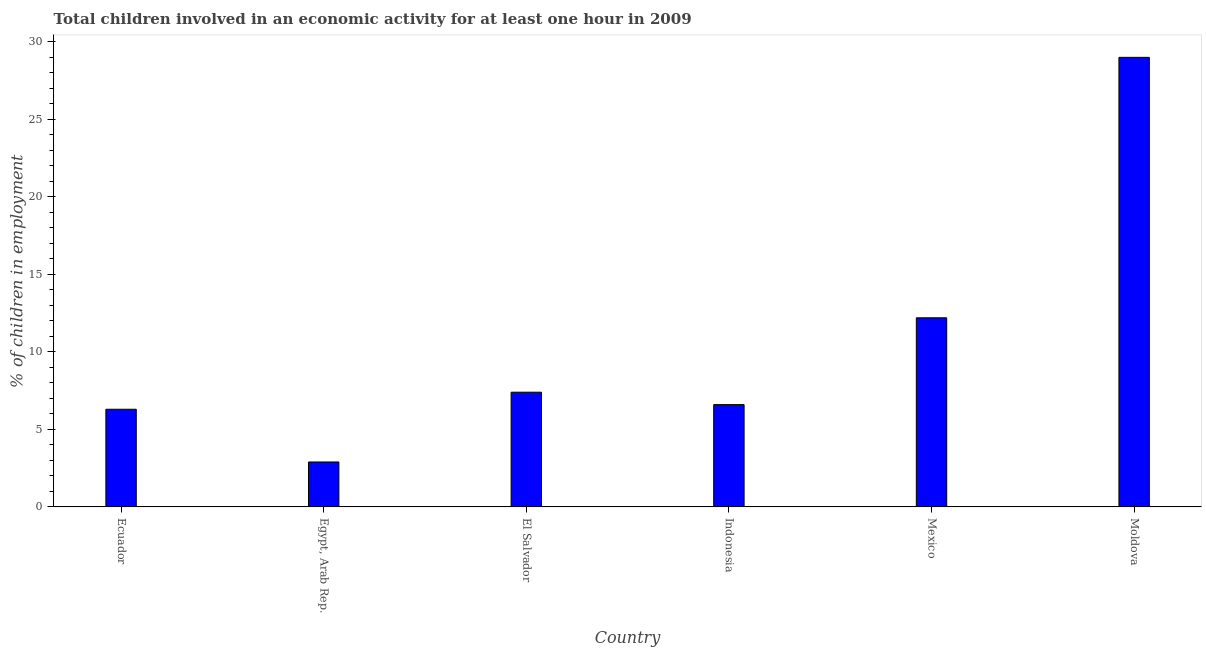Does the graph contain any zero values?
Ensure brevity in your answer.  No. Does the graph contain grids?
Make the answer very short. No. What is the title of the graph?
Keep it short and to the point. Total children involved in an economic activity for at least one hour in 2009. What is the label or title of the Y-axis?
Provide a short and direct response. % of children in employment. In which country was the percentage of children in employment maximum?
Your answer should be compact. Moldova. In which country was the percentage of children in employment minimum?
Give a very brief answer. Egypt, Arab Rep. What is the sum of the percentage of children in employment?
Give a very brief answer. 64.4. What is the average percentage of children in employment per country?
Your answer should be very brief. 10.73. In how many countries, is the percentage of children in employment greater than 22 %?
Offer a very short reply. 1. What is the ratio of the percentage of children in employment in Mexico to that in Moldova?
Your answer should be very brief. 0.42. Is the difference between the percentage of children in employment in El Salvador and Mexico greater than the difference between any two countries?
Offer a very short reply. No. What is the difference between the highest and the second highest percentage of children in employment?
Keep it short and to the point. 16.8. What is the difference between the highest and the lowest percentage of children in employment?
Provide a succinct answer. 26.1. What is the difference between two consecutive major ticks on the Y-axis?
Offer a terse response. 5. Are the values on the major ticks of Y-axis written in scientific E-notation?
Offer a very short reply. No. What is the % of children in employment of Egypt, Arab Rep.?
Offer a terse response. 2.9. What is the % of children in employment in El Salvador?
Provide a short and direct response. 7.4. What is the % of children in employment in Mexico?
Provide a succinct answer. 12.2. What is the % of children in employment in Moldova?
Ensure brevity in your answer.  29. What is the difference between the % of children in employment in Ecuador and Moldova?
Give a very brief answer. -22.7. What is the difference between the % of children in employment in Egypt, Arab Rep. and El Salvador?
Offer a terse response. -4.5. What is the difference between the % of children in employment in Egypt, Arab Rep. and Indonesia?
Your answer should be compact. -3.7. What is the difference between the % of children in employment in Egypt, Arab Rep. and Moldova?
Your response must be concise. -26.1. What is the difference between the % of children in employment in El Salvador and Moldova?
Offer a terse response. -21.6. What is the difference between the % of children in employment in Indonesia and Moldova?
Provide a short and direct response. -22.4. What is the difference between the % of children in employment in Mexico and Moldova?
Your response must be concise. -16.8. What is the ratio of the % of children in employment in Ecuador to that in Egypt, Arab Rep.?
Give a very brief answer. 2.17. What is the ratio of the % of children in employment in Ecuador to that in El Salvador?
Your answer should be very brief. 0.85. What is the ratio of the % of children in employment in Ecuador to that in Indonesia?
Your response must be concise. 0.95. What is the ratio of the % of children in employment in Ecuador to that in Mexico?
Your answer should be compact. 0.52. What is the ratio of the % of children in employment in Ecuador to that in Moldova?
Your answer should be compact. 0.22. What is the ratio of the % of children in employment in Egypt, Arab Rep. to that in El Salvador?
Your response must be concise. 0.39. What is the ratio of the % of children in employment in Egypt, Arab Rep. to that in Indonesia?
Give a very brief answer. 0.44. What is the ratio of the % of children in employment in Egypt, Arab Rep. to that in Mexico?
Provide a short and direct response. 0.24. What is the ratio of the % of children in employment in Egypt, Arab Rep. to that in Moldova?
Your answer should be very brief. 0.1. What is the ratio of the % of children in employment in El Salvador to that in Indonesia?
Offer a terse response. 1.12. What is the ratio of the % of children in employment in El Salvador to that in Mexico?
Offer a very short reply. 0.61. What is the ratio of the % of children in employment in El Salvador to that in Moldova?
Your response must be concise. 0.26. What is the ratio of the % of children in employment in Indonesia to that in Mexico?
Ensure brevity in your answer.  0.54. What is the ratio of the % of children in employment in Indonesia to that in Moldova?
Provide a short and direct response. 0.23. What is the ratio of the % of children in employment in Mexico to that in Moldova?
Provide a short and direct response. 0.42. 